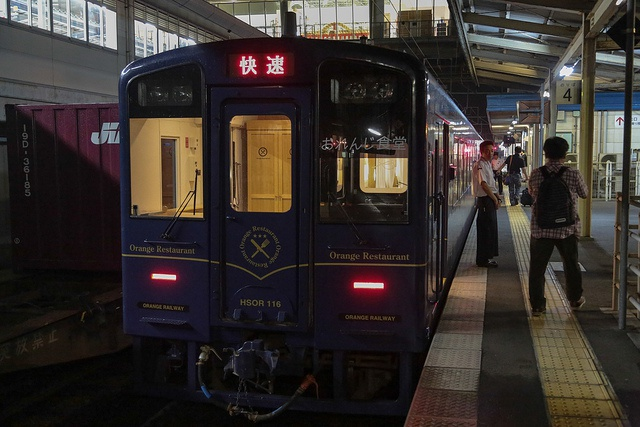Describe the objects in this image and their specific colors. I can see train in lightgray, black, gray, maroon, and tan tones, people in lightgray, black, and gray tones, people in lightgray, black, gray, and maroon tones, backpack in lightgray, black, and gray tones, and people in lightgray, black, gray, and maroon tones in this image. 